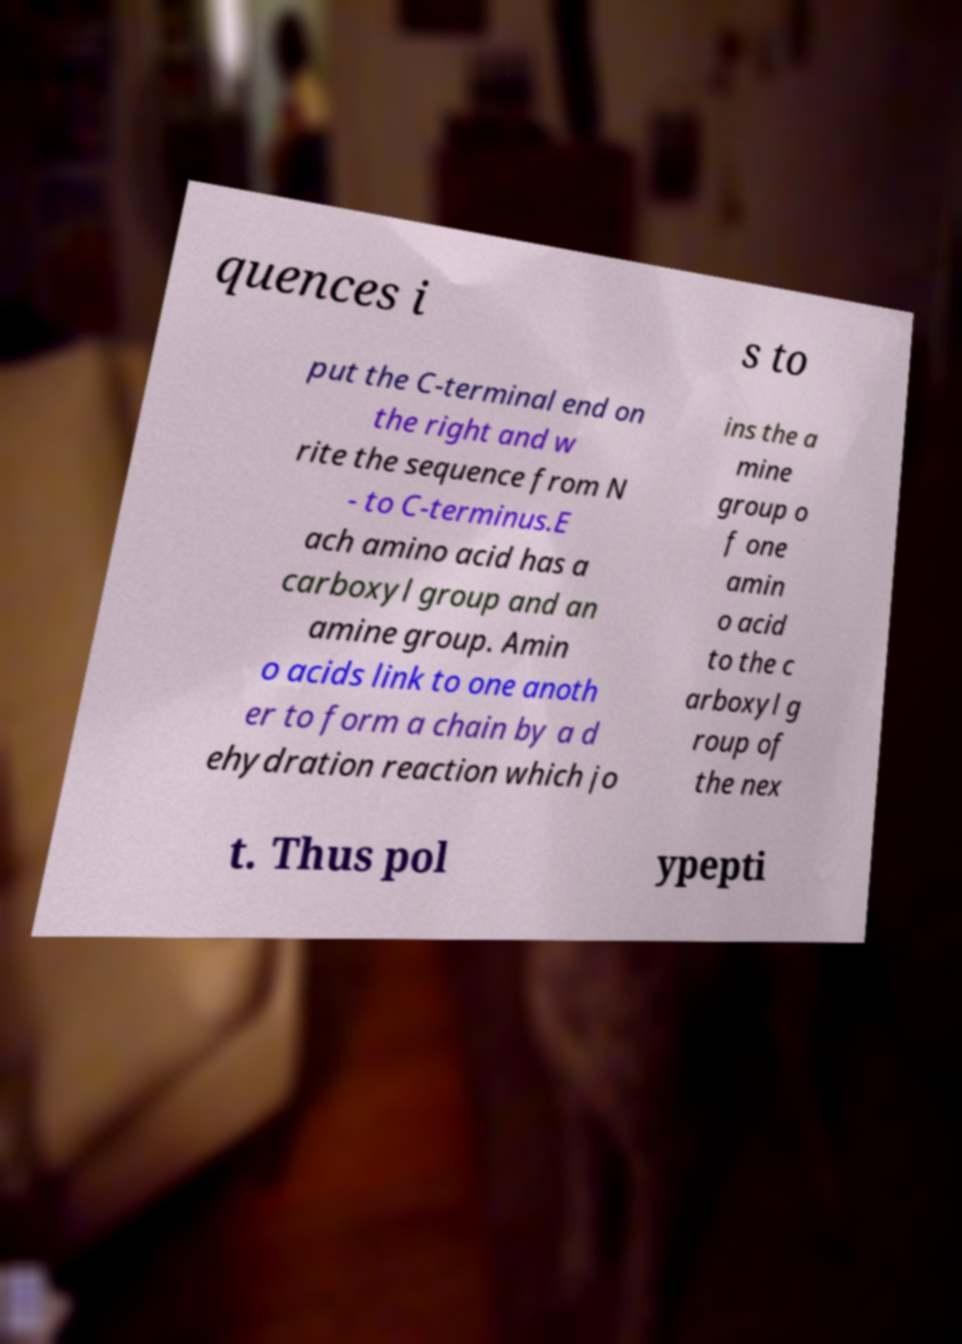Could you assist in decoding the text presented in this image and type it out clearly? quences i s to put the C-terminal end on the right and w rite the sequence from N - to C-terminus.E ach amino acid has a carboxyl group and an amine group. Amin o acids link to one anoth er to form a chain by a d ehydration reaction which jo ins the a mine group o f one amin o acid to the c arboxyl g roup of the nex t. Thus pol ypepti 